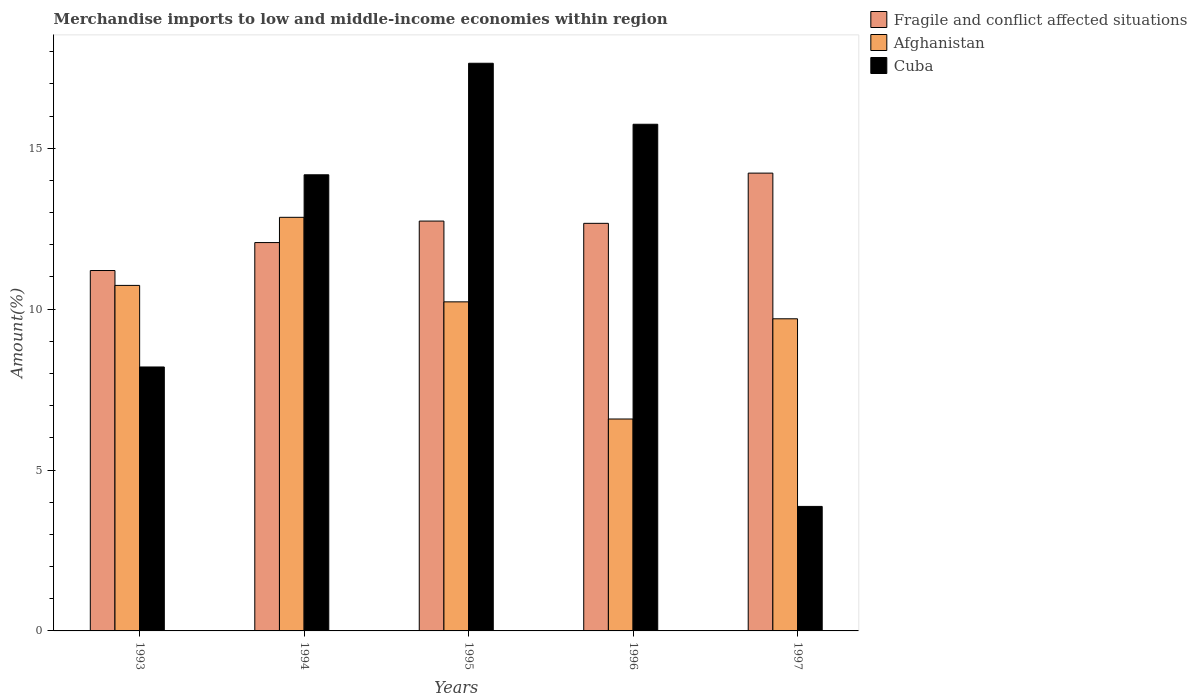How many different coloured bars are there?
Your answer should be compact. 3. Are the number of bars on each tick of the X-axis equal?
Make the answer very short. Yes. How many bars are there on the 3rd tick from the left?
Provide a short and direct response. 3. What is the label of the 5th group of bars from the left?
Offer a very short reply. 1997. In how many cases, is the number of bars for a given year not equal to the number of legend labels?
Offer a very short reply. 0. What is the percentage of amount earned from merchandise imports in Cuba in 1996?
Provide a succinct answer. 15.75. Across all years, what is the maximum percentage of amount earned from merchandise imports in Fragile and conflict affected situations?
Your answer should be very brief. 14.23. Across all years, what is the minimum percentage of amount earned from merchandise imports in Cuba?
Offer a very short reply. 3.87. What is the total percentage of amount earned from merchandise imports in Fragile and conflict affected situations in the graph?
Give a very brief answer. 62.9. What is the difference between the percentage of amount earned from merchandise imports in Afghanistan in 1995 and that in 1997?
Your response must be concise. 0.53. What is the difference between the percentage of amount earned from merchandise imports in Fragile and conflict affected situations in 1993 and the percentage of amount earned from merchandise imports in Afghanistan in 1994?
Your answer should be very brief. -1.65. What is the average percentage of amount earned from merchandise imports in Cuba per year?
Make the answer very short. 11.93. In the year 1997, what is the difference between the percentage of amount earned from merchandise imports in Cuba and percentage of amount earned from merchandise imports in Afghanistan?
Your answer should be compact. -5.83. In how many years, is the percentage of amount earned from merchandise imports in Afghanistan greater than 14 %?
Offer a terse response. 0. What is the ratio of the percentage of amount earned from merchandise imports in Afghanistan in 1995 to that in 1997?
Provide a short and direct response. 1.05. Is the percentage of amount earned from merchandise imports in Afghanistan in 1993 less than that in 1995?
Provide a succinct answer. No. Is the difference between the percentage of amount earned from merchandise imports in Cuba in 1993 and 1995 greater than the difference between the percentage of amount earned from merchandise imports in Afghanistan in 1993 and 1995?
Your response must be concise. No. What is the difference between the highest and the second highest percentage of amount earned from merchandise imports in Afghanistan?
Offer a terse response. 2.12. What is the difference between the highest and the lowest percentage of amount earned from merchandise imports in Afghanistan?
Offer a terse response. 6.27. In how many years, is the percentage of amount earned from merchandise imports in Cuba greater than the average percentage of amount earned from merchandise imports in Cuba taken over all years?
Ensure brevity in your answer.  3. Is the sum of the percentage of amount earned from merchandise imports in Cuba in 1994 and 1996 greater than the maximum percentage of amount earned from merchandise imports in Afghanistan across all years?
Your response must be concise. Yes. What does the 1st bar from the left in 1994 represents?
Your response must be concise. Fragile and conflict affected situations. What does the 1st bar from the right in 1995 represents?
Your response must be concise. Cuba. Are all the bars in the graph horizontal?
Make the answer very short. No. How many years are there in the graph?
Keep it short and to the point. 5. What is the difference between two consecutive major ticks on the Y-axis?
Ensure brevity in your answer.  5. Are the values on the major ticks of Y-axis written in scientific E-notation?
Provide a succinct answer. No. Where does the legend appear in the graph?
Offer a terse response. Top right. How are the legend labels stacked?
Offer a terse response. Vertical. What is the title of the graph?
Your answer should be compact. Merchandise imports to low and middle-income economies within region. Does "Barbados" appear as one of the legend labels in the graph?
Offer a very short reply. No. What is the label or title of the X-axis?
Ensure brevity in your answer.  Years. What is the label or title of the Y-axis?
Give a very brief answer. Amount(%). What is the Amount(%) in Fragile and conflict affected situations in 1993?
Provide a succinct answer. 11.2. What is the Amount(%) of Afghanistan in 1993?
Keep it short and to the point. 10.74. What is the Amount(%) in Cuba in 1993?
Your answer should be compact. 8.2. What is the Amount(%) in Fragile and conflict affected situations in 1994?
Provide a succinct answer. 12.07. What is the Amount(%) in Afghanistan in 1994?
Your answer should be compact. 12.85. What is the Amount(%) in Cuba in 1994?
Your response must be concise. 14.18. What is the Amount(%) in Fragile and conflict affected situations in 1995?
Ensure brevity in your answer.  12.74. What is the Amount(%) of Afghanistan in 1995?
Provide a short and direct response. 10.23. What is the Amount(%) of Cuba in 1995?
Your answer should be compact. 17.64. What is the Amount(%) of Fragile and conflict affected situations in 1996?
Your response must be concise. 12.67. What is the Amount(%) of Afghanistan in 1996?
Offer a terse response. 6.59. What is the Amount(%) in Cuba in 1996?
Make the answer very short. 15.75. What is the Amount(%) in Fragile and conflict affected situations in 1997?
Offer a very short reply. 14.23. What is the Amount(%) in Afghanistan in 1997?
Offer a terse response. 9.7. What is the Amount(%) in Cuba in 1997?
Offer a very short reply. 3.87. Across all years, what is the maximum Amount(%) in Fragile and conflict affected situations?
Offer a terse response. 14.23. Across all years, what is the maximum Amount(%) of Afghanistan?
Your answer should be compact. 12.85. Across all years, what is the maximum Amount(%) in Cuba?
Ensure brevity in your answer.  17.64. Across all years, what is the minimum Amount(%) of Fragile and conflict affected situations?
Your response must be concise. 11.2. Across all years, what is the minimum Amount(%) in Afghanistan?
Offer a terse response. 6.59. Across all years, what is the minimum Amount(%) in Cuba?
Make the answer very short. 3.87. What is the total Amount(%) in Fragile and conflict affected situations in the graph?
Offer a terse response. 62.9. What is the total Amount(%) of Afghanistan in the graph?
Ensure brevity in your answer.  50.11. What is the total Amount(%) in Cuba in the graph?
Provide a succinct answer. 59.64. What is the difference between the Amount(%) of Fragile and conflict affected situations in 1993 and that in 1994?
Your response must be concise. -0.87. What is the difference between the Amount(%) of Afghanistan in 1993 and that in 1994?
Your answer should be very brief. -2.12. What is the difference between the Amount(%) of Cuba in 1993 and that in 1994?
Provide a short and direct response. -5.97. What is the difference between the Amount(%) of Fragile and conflict affected situations in 1993 and that in 1995?
Provide a short and direct response. -1.54. What is the difference between the Amount(%) in Afghanistan in 1993 and that in 1995?
Your response must be concise. 0.51. What is the difference between the Amount(%) in Cuba in 1993 and that in 1995?
Offer a very short reply. -9.44. What is the difference between the Amount(%) of Fragile and conflict affected situations in 1993 and that in 1996?
Keep it short and to the point. -1.47. What is the difference between the Amount(%) of Afghanistan in 1993 and that in 1996?
Make the answer very short. 4.15. What is the difference between the Amount(%) in Cuba in 1993 and that in 1996?
Keep it short and to the point. -7.54. What is the difference between the Amount(%) of Fragile and conflict affected situations in 1993 and that in 1997?
Provide a succinct answer. -3.03. What is the difference between the Amount(%) in Afghanistan in 1993 and that in 1997?
Give a very brief answer. 1.04. What is the difference between the Amount(%) of Cuba in 1993 and that in 1997?
Offer a terse response. 4.33. What is the difference between the Amount(%) in Fragile and conflict affected situations in 1994 and that in 1995?
Ensure brevity in your answer.  -0.67. What is the difference between the Amount(%) of Afghanistan in 1994 and that in 1995?
Ensure brevity in your answer.  2.63. What is the difference between the Amount(%) of Cuba in 1994 and that in 1995?
Ensure brevity in your answer.  -3.47. What is the difference between the Amount(%) in Fragile and conflict affected situations in 1994 and that in 1996?
Keep it short and to the point. -0.6. What is the difference between the Amount(%) of Afghanistan in 1994 and that in 1996?
Your answer should be very brief. 6.27. What is the difference between the Amount(%) in Cuba in 1994 and that in 1996?
Your answer should be compact. -1.57. What is the difference between the Amount(%) in Fragile and conflict affected situations in 1994 and that in 1997?
Your answer should be very brief. -2.16. What is the difference between the Amount(%) of Afghanistan in 1994 and that in 1997?
Your response must be concise. 3.15. What is the difference between the Amount(%) in Cuba in 1994 and that in 1997?
Make the answer very short. 10.31. What is the difference between the Amount(%) in Fragile and conflict affected situations in 1995 and that in 1996?
Give a very brief answer. 0.07. What is the difference between the Amount(%) of Afghanistan in 1995 and that in 1996?
Make the answer very short. 3.64. What is the difference between the Amount(%) in Cuba in 1995 and that in 1996?
Give a very brief answer. 1.9. What is the difference between the Amount(%) of Fragile and conflict affected situations in 1995 and that in 1997?
Offer a terse response. -1.49. What is the difference between the Amount(%) in Afghanistan in 1995 and that in 1997?
Offer a terse response. 0.53. What is the difference between the Amount(%) of Cuba in 1995 and that in 1997?
Your answer should be compact. 13.77. What is the difference between the Amount(%) of Fragile and conflict affected situations in 1996 and that in 1997?
Ensure brevity in your answer.  -1.56. What is the difference between the Amount(%) of Afghanistan in 1996 and that in 1997?
Give a very brief answer. -3.11. What is the difference between the Amount(%) in Cuba in 1996 and that in 1997?
Ensure brevity in your answer.  11.88. What is the difference between the Amount(%) in Fragile and conflict affected situations in 1993 and the Amount(%) in Afghanistan in 1994?
Keep it short and to the point. -1.65. What is the difference between the Amount(%) in Fragile and conflict affected situations in 1993 and the Amount(%) in Cuba in 1994?
Provide a short and direct response. -2.98. What is the difference between the Amount(%) of Afghanistan in 1993 and the Amount(%) of Cuba in 1994?
Give a very brief answer. -3.44. What is the difference between the Amount(%) in Fragile and conflict affected situations in 1993 and the Amount(%) in Afghanistan in 1995?
Give a very brief answer. 0.97. What is the difference between the Amount(%) in Fragile and conflict affected situations in 1993 and the Amount(%) in Cuba in 1995?
Your answer should be very brief. -6.44. What is the difference between the Amount(%) of Afghanistan in 1993 and the Amount(%) of Cuba in 1995?
Provide a succinct answer. -6.9. What is the difference between the Amount(%) of Fragile and conflict affected situations in 1993 and the Amount(%) of Afghanistan in 1996?
Give a very brief answer. 4.61. What is the difference between the Amount(%) of Fragile and conflict affected situations in 1993 and the Amount(%) of Cuba in 1996?
Keep it short and to the point. -4.55. What is the difference between the Amount(%) in Afghanistan in 1993 and the Amount(%) in Cuba in 1996?
Provide a succinct answer. -5.01. What is the difference between the Amount(%) of Fragile and conflict affected situations in 1993 and the Amount(%) of Afghanistan in 1997?
Offer a terse response. 1.5. What is the difference between the Amount(%) of Fragile and conflict affected situations in 1993 and the Amount(%) of Cuba in 1997?
Make the answer very short. 7.33. What is the difference between the Amount(%) of Afghanistan in 1993 and the Amount(%) of Cuba in 1997?
Provide a succinct answer. 6.87. What is the difference between the Amount(%) of Fragile and conflict affected situations in 1994 and the Amount(%) of Afghanistan in 1995?
Give a very brief answer. 1.84. What is the difference between the Amount(%) of Fragile and conflict affected situations in 1994 and the Amount(%) of Cuba in 1995?
Ensure brevity in your answer.  -5.57. What is the difference between the Amount(%) in Afghanistan in 1994 and the Amount(%) in Cuba in 1995?
Make the answer very short. -4.79. What is the difference between the Amount(%) in Fragile and conflict affected situations in 1994 and the Amount(%) in Afghanistan in 1996?
Give a very brief answer. 5.48. What is the difference between the Amount(%) of Fragile and conflict affected situations in 1994 and the Amount(%) of Cuba in 1996?
Offer a very short reply. -3.68. What is the difference between the Amount(%) in Afghanistan in 1994 and the Amount(%) in Cuba in 1996?
Provide a succinct answer. -2.89. What is the difference between the Amount(%) of Fragile and conflict affected situations in 1994 and the Amount(%) of Afghanistan in 1997?
Your answer should be compact. 2.37. What is the difference between the Amount(%) in Fragile and conflict affected situations in 1994 and the Amount(%) in Cuba in 1997?
Provide a short and direct response. 8.2. What is the difference between the Amount(%) of Afghanistan in 1994 and the Amount(%) of Cuba in 1997?
Provide a short and direct response. 8.98. What is the difference between the Amount(%) in Fragile and conflict affected situations in 1995 and the Amount(%) in Afghanistan in 1996?
Provide a succinct answer. 6.15. What is the difference between the Amount(%) of Fragile and conflict affected situations in 1995 and the Amount(%) of Cuba in 1996?
Provide a succinct answer. -3.01. What is the difference between the Amount(%) in Afghanistan in 1995 and the Amount(%) in Cuba in 1996?
Keep it short and to the point. -5.52. What is the difference between the Amount(%) of Fragile and conflict affected situations in 1995 and the Amount(%) of Afghanistan in 1997?
Provide a short and direct response. 3.04. What is the difference between the Amount(%) in Fragile and conflict affected situations in 1995 and the Amount(%) in Cuba in 1997?
Provide a succinct answer. 8.87. What is the difference between the Amount(%) of Afghanistan in 1995 and the Amount(%) of Cuba in 1997?
Keep it short and to the point. 6.36. What is the difference between the Amount(%) of Fragile and conflict affected situations in 1996 and the Amount(%) of Afghanistan in 1997?
Offer a very short reply. 2.97. What is the difference between the Amount(%) of Fragile and conflict affected situations in 1996 and the Amount(%) of Cuba in 1997?
Your response must be concise. 8.8. What is the difference between the Amount(%) of Afghanistan in 1996 and the Amount(%) of Cuba in 1997?
Provide a short and direct response. 2.72. What is the average Amount(%) in Fragile and conflict affected situations per year?
Your response must be concise. 12.58. What is the average Amount(%) of Afghanistan per year?
Keep it short and to the point. 10.02. What is the average Amount(%) in Cuba per year?
Offer a terse response. 11.93. In the year 1993, what is the difference between the Amount(%) of Fragile and conflict affected situations and Amount(%) of Afghanistan?
Make the answer very short. 0.46. In the year 1993, what is the difference between the Amount(%) of Fragile and conflict affected situations and Amount(%) of Cuba?
Your answer should be very brief. 3. In the year 1993, what is the difference between the Amount(%) of Afghanistan and Amount(%) of Cuba?
Make the answer very short. 2.54. In the year 1994, what is the difference between the Amount(%) of Fragile and conflict affected situations and Amount(%) of Afghanistan?
Provide a short and direct response. -0.78. In the year 1994, what is the difference between the Amount(%) of Fragile and conflict affected situations and Amount(%) of Cuba?
Your answer should be compact. -2.11. In the year 1994, what is the difference between the Amount(%) of Afghanistan and Amount(%) of Cuba?
Your answer should be very brief. -1.32. In the year 1995, what is the difference between the Amount(%) of Fragile and conflict affected situations and Amount(%) of Afghanistan?
Your response must be concise. 2.51. In the year 1995, what is the difference between the Amount(%) in Fragile and conflict affected situations and Amount(%) in Cuba?
Offer a very short reply. -4.9. In the year 1995, what is the difference between the Amount(%) of Afghanistan and Amount(%) of Cuba?
Give a very brief answer. -7.42. In the year 1996, what is the difference between the Amount(%) in Fragile and conflict affected situations and Amount(%) in Afghanistan?
Keep it short and to the point. 6.08. In the year 1996, what is the difference between the Amount(%) in Fragile and conflict affected situations and Amount(%) in Cuba?
Provide a short and direct response. -3.08. In the year 1996, what is the difference between the Amount(%) of Afghanistan and Amount(%) of Cuba?
Offer a terse response. -9.16. In the year 1997, what is the difference between the Amount(%) in Fragile and conflict affected situations and Amount(%) in Afghanistan?
Offer a terse response. 4.53. In the year 1997, what is the difference between the Amount(%) of Fragile and conflict affected situations and Amount(%) of Cuba?
Your response must be concise. 10.36. In the year 1997, what is the difference between the Amount(%) of Afghanistan and Amount(%) of Cuba?
Your response must be concise. 5.83. What is the ratio of the Amount(%) of Fragile and conflict affected situations in 1993 to that in 1994?
Provide a succinct answer. 0.93. What is the ratio of the Amount(%) in Afghanistan in 1993 to that in 1994?
Provide a short and direct response. 0.84. What is the ratio of the Amount(%) of Cuba in 1993 to that in 1994?
Ensure brevity in your answer.  0.58. What is the ratio of the Amount(%) of Fragile and conflict affected situations in 1993 to that in 1995?
Provide a succinct answer. 0.88. What is the ratio of the Amount(%) of Afghanistan in 1993 to that in 1995?
Your answer should be compact. 1.05. What is the ratio of the Amount(%) of Cuba in 1993 to that in 1995?
Offer a terse response. 0.47. What is the ratio of the Amount(%) in Fragile and conflict affected situations in 1993 to that in 1996?
Offer a very short reply. 0.88. What is the ratio of the Amount(%) in Afghanistan in 1993 to that in 1996?
Make the answer very short. 1.63. What is the ratio of the Amount(%) of Cuba in 1993 to that in 1996?
Offer a terse response. 0.52. What is the ratio of the Amount(%) in Fragile and conflict affected situations in 1993 to that in 1997?
Your answer should be very brief. 0.79. What is the ratio of the Amount(%) of Afghanistan in 1993 to that in 1997?
Ensure brevity in your answer.  1.11. What is the ratio of the Amount(%) of Cuba in 1993 to that in 1997?
Offer a terse response. 2.12. What is the ratio of the Amount(%) of Fragile and conflict affected situations in 1994 to that in 1995?
Provide a short and direct response. 0.95. What is the ratio of the Amount(%) of Afghanistan in 1994 to that in 1995?
Offer a terse response. 1.26. What is the ratio of the Amount(%) of Cuba in 1994 to that in 1995?
Ensure brevity in your answer.  0.8. What is the ratio of the Amount(%) of Fragile and conflict affected situations in 1994 to that in 1996?
Your answer should be compact. 0.95. What is the ratio of the Amount(%) in Afghanistan in 1994 to that in 1996?
Your answer should be compact. 1.95. What is the ratio of the Amount(%) in Cuba in 1994 to that in 1996?
Make the answer very short. 0.9. What is the ratio of the Amount(%) of Fragile and conflict affected situations in 1994 to that in 1997?
Keep it short and to the point. 0.85. What is the ratio of the Amount(%) of Afghanistan in 1994 to that in 1997?
Offer a very short reply. 1.33. What is the ratio of the Amount(%) in Cuba in 1994 to that in 1997?
Keep it short and to the point. 3.66. What is the ratio of the Amount(%) of Fragile and conflict affected situations in 1995 to that in 1996?
Provide a short and direct response. 1.01. What is the ratio of the Amount(%) of Afghanistan in 1995 to that in 1996?
Provide a short and direct response. 1.55. What is the ratio of the Amount(%) of Cuba in 1995 to that in 1996?
Offer a terse response. 1.12. What is the ratio of the Amount(%) in Fragile and conflict affected situations in 1995 to that in 1997?
Your answer should be very brief. 0.9. What is the ratio of the Amount(%) of Afghanistan in 1995 to that in 1997?
Provide a short and direct response. 1.05. What is the ratio of the Amount(%) in Cuba in 1995 to that in 1997?
Ensure brevity in your answer.  4.56. What is the ratio of the Amount(%) in Fragile and conflict affected situations in 1996 to that in 1997?
Give a very brief answer. 0.89. What is the ratio of the Amount(%) in Afghanistan in 1996 to that in 1997?
Provide a short and direct response. 0.68. What is the ratio of the Amount(%) in Cuba in 1996 to that in 1997?
Provide a short and direct response. 4.07. What is the difference between the highest and the second highest Amount(%) in Fragile and conflict affected situations?
Keep it short and to the point. 1.49. What is the difference between the highest and the second highest Amount(%) in Afghanistan?
Make the answer very short. 2.12. What is the difference between the highest and the second highest Amount(%) of Cuba?
Provide a succinct answer. 1.9. What is the difference between the highest and the lowest Amount(%) of Fragile and conflict affected situations?
Ensure brevity in your answer.  3.03. What is the difference between the highest and the lowest Amount(%) of Afghanistan?
Provide a short and direct response. 6.27. What is the difference between the highest and the lowest Amount(%) in Cuba?
Make the answer very short. 13.77. 